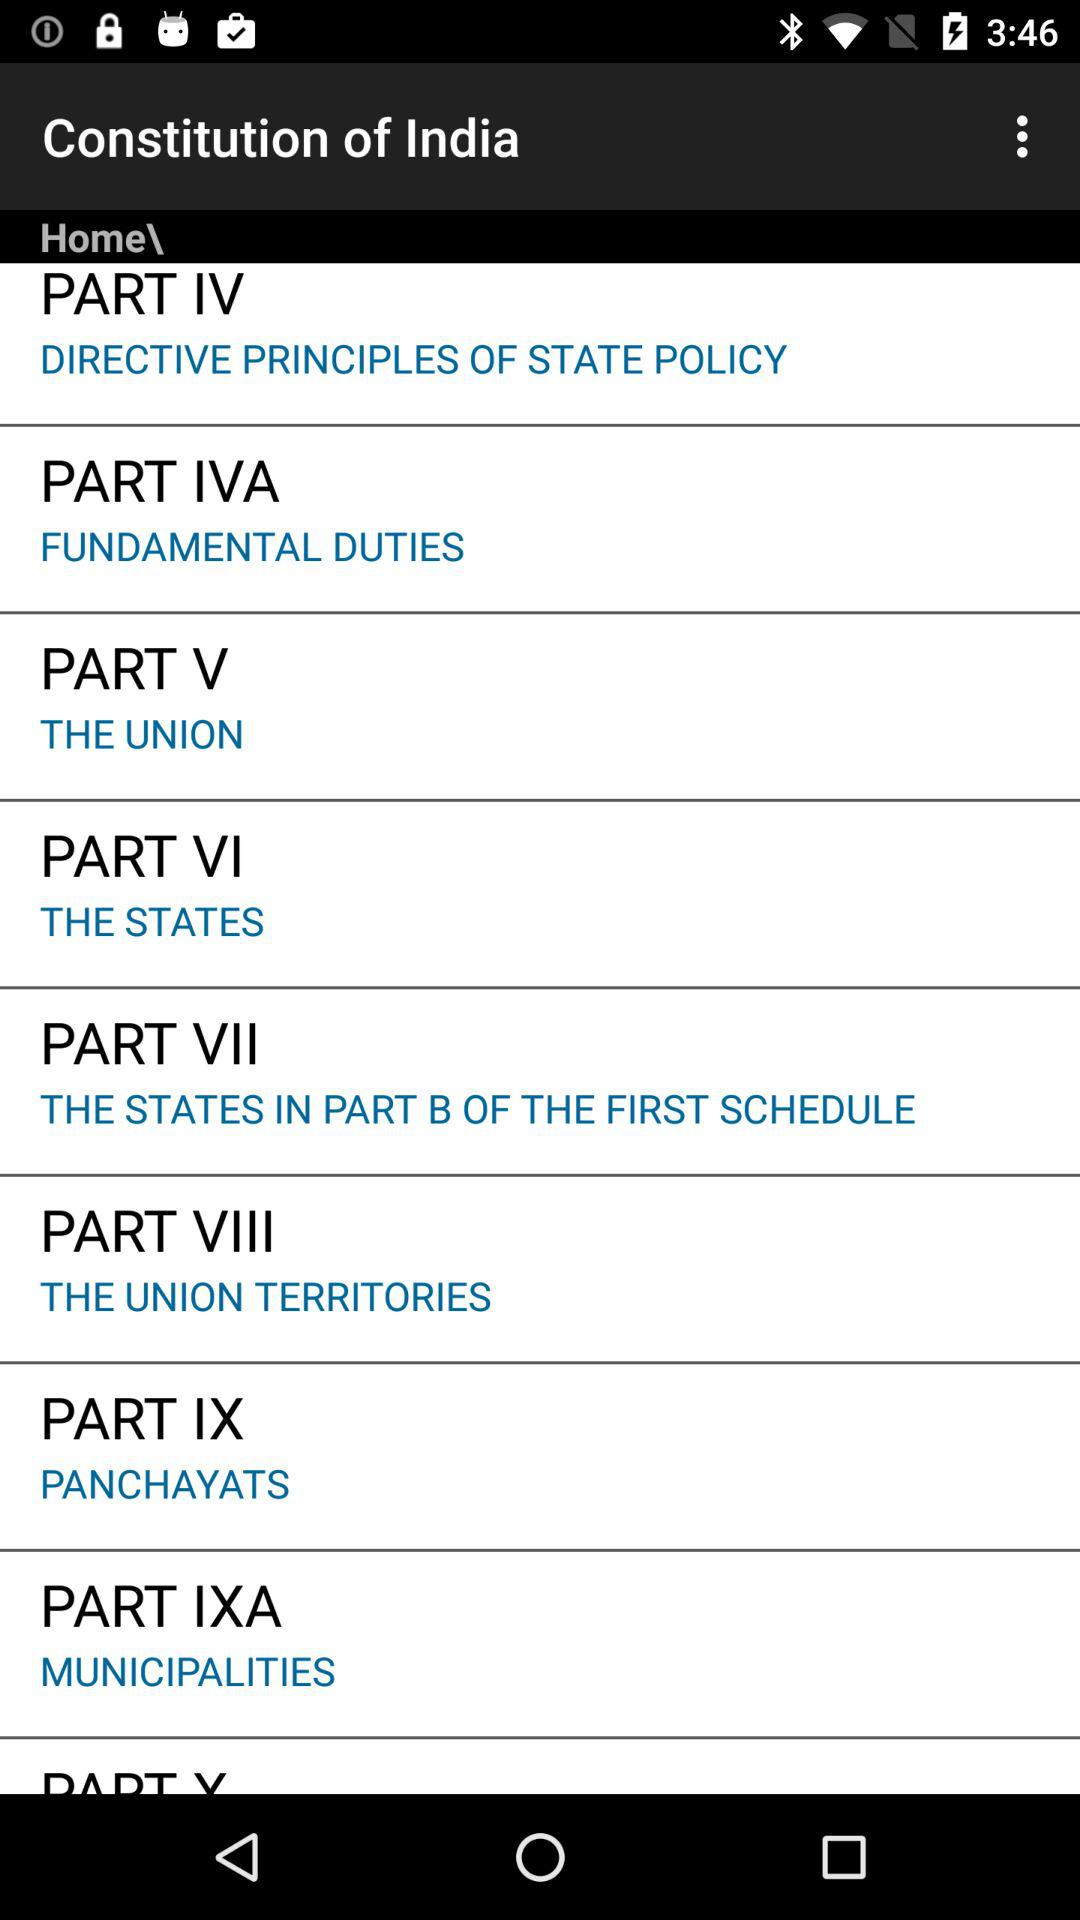What topic is related to part V? The topic is "THE UNION". 